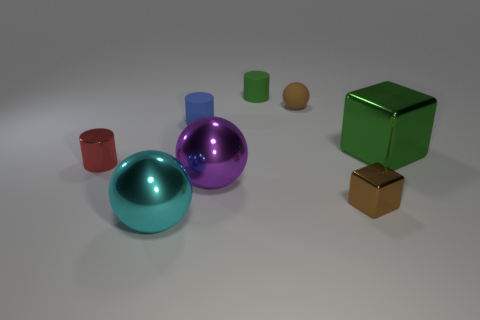There is a small object that is the same color as the matte ball; what material is it?
Your answer should be very brief. Metal. How many things are tiny brown objects or cylinders?
Offer a terse response. 5. Are there any cylinders of the same color as the small cube?
Provide a succinct answer. No. There is a large ball that is to the right of the large cyan ball; what number of small matte things are to the right of it?
Provide a succinct answer. 2. Are there more big gray shiny cylinders than matte cylinders?
Make the answer very short. No. Does the small green thing have the same material as the blue cylinder?
Keep it short and to the point. Yes. Are there an equal number of tiny red cylinders that are right of the small metal block and tiny brown metallic things?
Offer a terse response. No. What number of small red blocks have the same material as the cyan ball?
Your answer should be very brief. 0. Are there fewer red matte cylinders than green objects?
Ensure brevity in your answer.  Yes. There is a cylinder that is to the right of the blue object; is its color the same as the big cube?
Make the answer very short. Yes. 